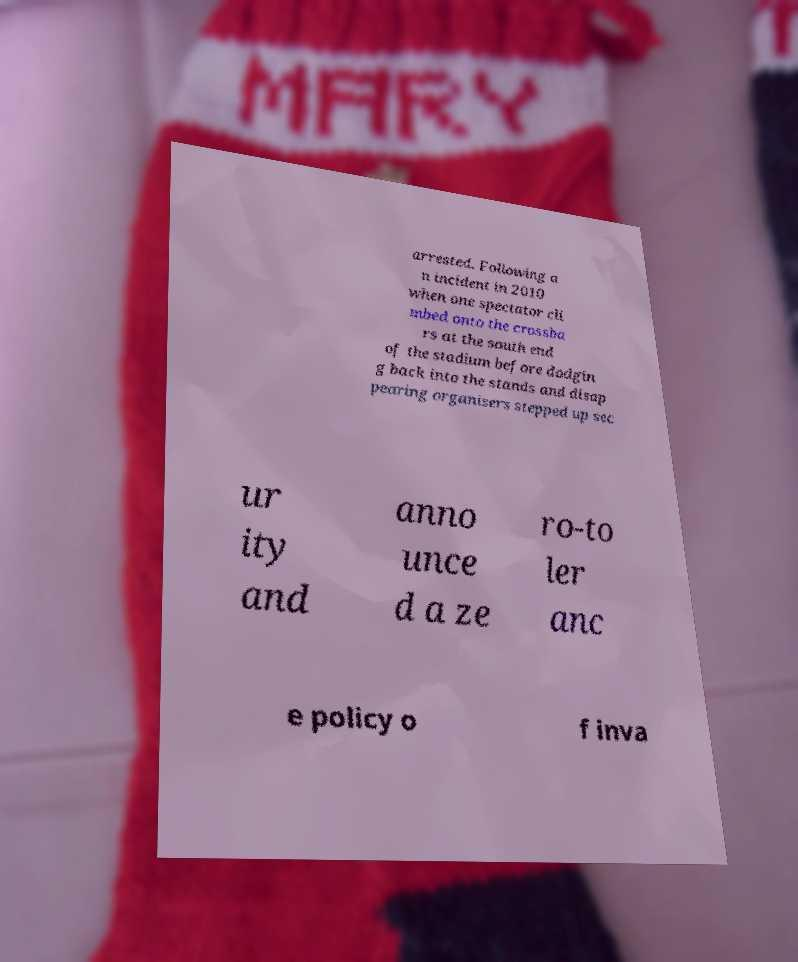Could you extract and type out the text from this image? arrested. Following a n incident in 2010 when one spectator cli mbed onto the crossba rs at the south end of the stadium before dodgin g back into the stands and disap pearing organisers stepped up sec ur ity and anno unce d a ze ro-to ler anc e policy o f inva 